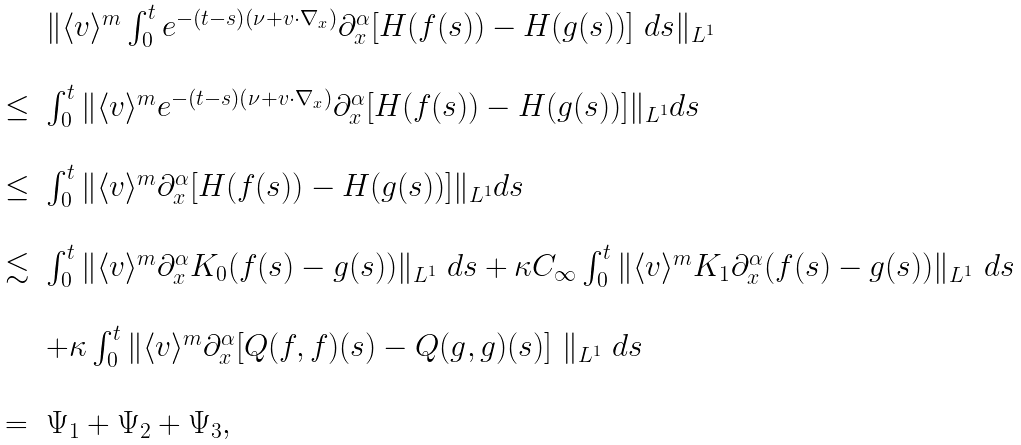<formula> <loc_0><loc_0><loc_500><loc_500>\begin{array} { l l l } & & \| \langle v \rangle ^ { m } \int _ { 0 } ^ { t } e ^ { - ( t - s ) ( \nu + v \cdot \nabla _ { x } ) } \partial _ { x } ^ { \alpha } [ H ( f ( s ) ) - H ( g ( s ) ) ] \ d s \| _ { L ^ { 1 } } \\ & & \\ & \leq & \int _ { 0 } ^ { t } \| \langle v \rangle ^ { m } e ^ { - ( t - s ) ( \nu + v \cdot \nabla _ { x } ) } \partial _ { x } ^ { \alpha } [ H ( f ( s ) ) - H ( g ( s ) ) ] \| _ { L ^ { 1 } } d s \\ & & \\ & \leq & \int _ { 0 } ^ { t } \| \langle v \rangle ^ { m } \partial _ { x } ^ { \alpha } [ H ( f ( s ) ) - H ( g ( s ) ) ] \| _ { L ^ { 1 } } d s \\ & & \\ & \lesssim & \int _ { 0 } ^ { t } \| \langle v \rangle ^ { m } \partial _ { x } ^ { \alpha } K _ { 0 } ( f ( s ) - g ( s ) ) \| _ { L ^ { 1 } } \ d s + \kappa C _ { \infty } \int _ { 0 } ^ { t } \| \langle v \rangle ^ { m } K _ { 1 } \partial _ { x } ^ { \alpha } ( f ( s ) - g ( s ) ) \| _ { L ^ { 1 } } \ d s \\ & & \\ & & + \kappa \int _ { 0 } ^ { t } \| \langle v \rangle ^ { m } \partial _ { x } ^ { \alpha } [ Q ( f , f ) ( s ) - Q ( g , g ) ( s ) ] \ \| _ { L ^ { 1 } } \ d s \\ & & \\ & = & \Psi _ { 1 } + \Psi _ { 2 } + \Psi _ { 3 } , \end{array}</formula> 